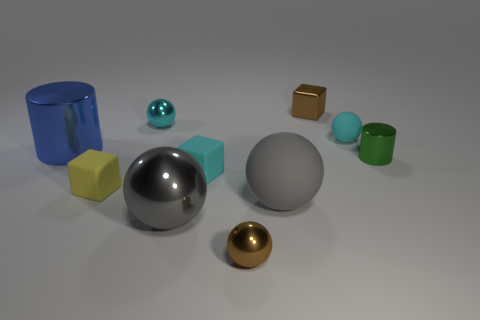Are there an equal number of small rubber objects that are to the left of the tiny brown sphere and large blue shiny cylinders?
Your response must be concise. No. There is a yellow rubber object; does it have the same shape as the brown thing that is behind the small green metal thing?
Provide a short and direct response. Yes. What is the size of the other cyan object that is the same shape as the small cyan shiny object?
Make the answer very short. Small. What number of other objects are the same material as the large blue cylinder?
Offer a very short reply. 5. What material is the tiny yellow block?
Offer a very short reply. Rubber. There is a large metal object on the right side of the cyan shiny sphere; is it the same color as the matte sphere that is in front of the blue metal thing?
Your response must be concise. Yes. Is the number of small cyan matte objects that are right of the gray matte object greater than the number of red rubber objects?
Keep it short and to the point. Yes. What number of other things are the same color as the large matte thing?
Keep it short and to the point. 1. There is a cyan object that is in front of the blue metallic object; does it have the same size as the yellow rubber object?
Offer a very short reply. Yes. Are there any gray rubber things of the same size as the blue cylinder?
Offer a very short reply. Yes. 